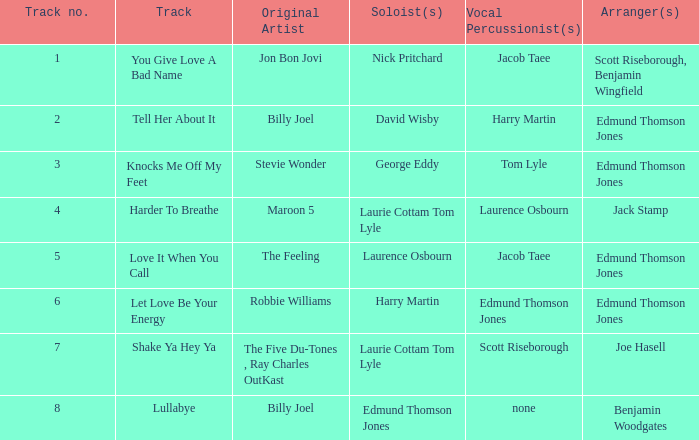Who arranged song(s) with tom lyle on the vocal percussion? Edmund Thomson Jones. 